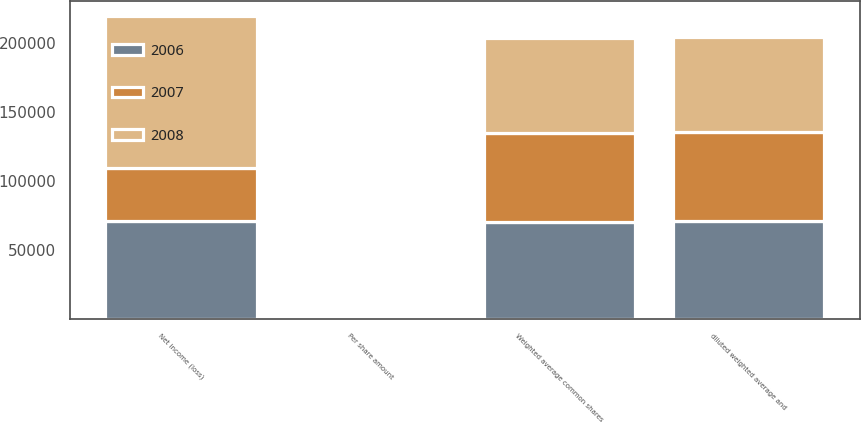Convert chart to OTSL. <chart><loc_0><loc_0><loc_500><loc_500><stacked_bar_chart><ecel><fcel>Net income (loss)<fcel>Weighted average common shares<fcel>Per share amount<fcel>diluted weighted average and<nl><fcel>2007<fcel>38421<fcel>64524<fcel>0.6<fcel>64524<nl><fcel>2008<fcel>110113<fcel>68463<fcel>1.61<fcel>68908<nl><fcel>2006<fcel>70946<fcel>70516<fcel>1.01<fcel>70956<nl></chart> 